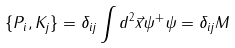Convert formula to latex. <formula><loc_0><loc_0><loc_500><loc_500>\{ P _ { i } , K _ { j } \} = \delta _ { i j } \int d ^ { 2 } \vec { x } \psi ^ { + } \psi = \delta _ { i j } M</formula> 